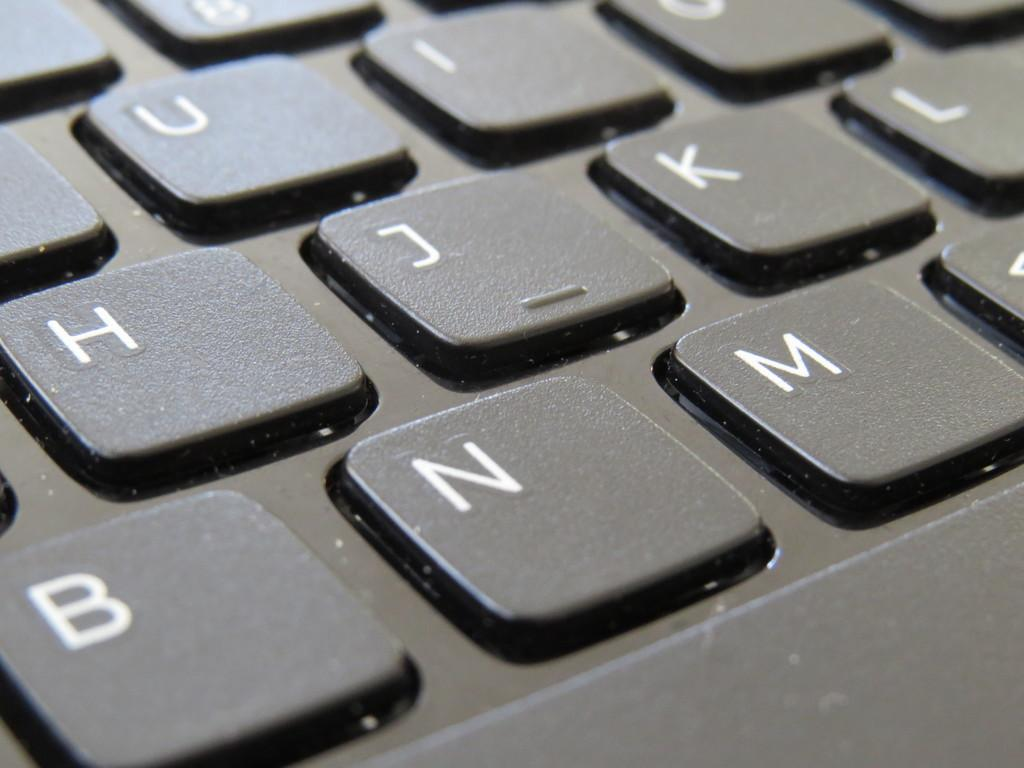What is the main object in the image? There is a keyboard in the image. What feature of the keyboard is mentioned in the facts? The keyboard has some letters on it. What type of animal is having a discussion with the keyboard in the image? There is no animal present in the image, and therefore no such discussion can be observed. What type of toy is visible interacting with the keyboard in the image? There is no toy present in the image; only the keyboard is visible. 